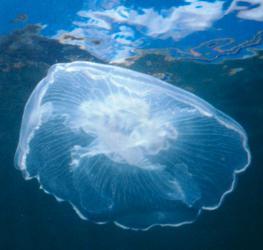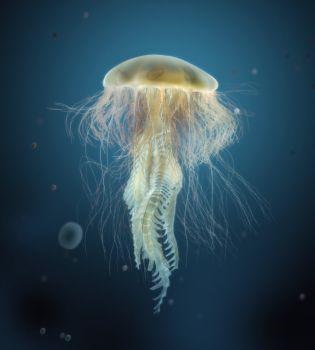The first image is the image on the left, the second image is the image on the right. Assess this claim about the two images: "All the organisms have long tentacles.". Correct or not? Answer yes or no. No. 